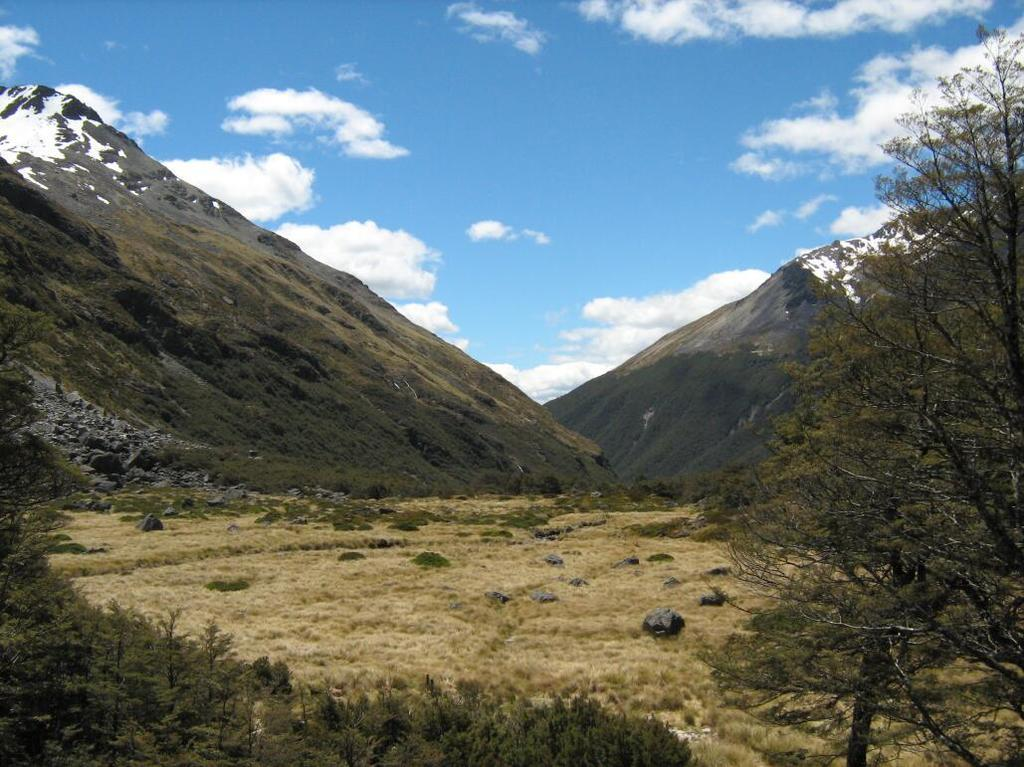What type of natural elements can be seen in the image? There are rocks, grass, plants, trees, and hills visible in the image. What type of vegetation is present in the image? There are plants and trees in the image. What is visible in the background of the image? The sky is visible in the background of the image. How many cherries are hanging from the trees in the image? There are no cherries present in the image; it features rocks, grass, plants, trees, hills, and the sky. What type of badge can be seen on the rocks in the image? There is no badge present on the rocks in the image. 